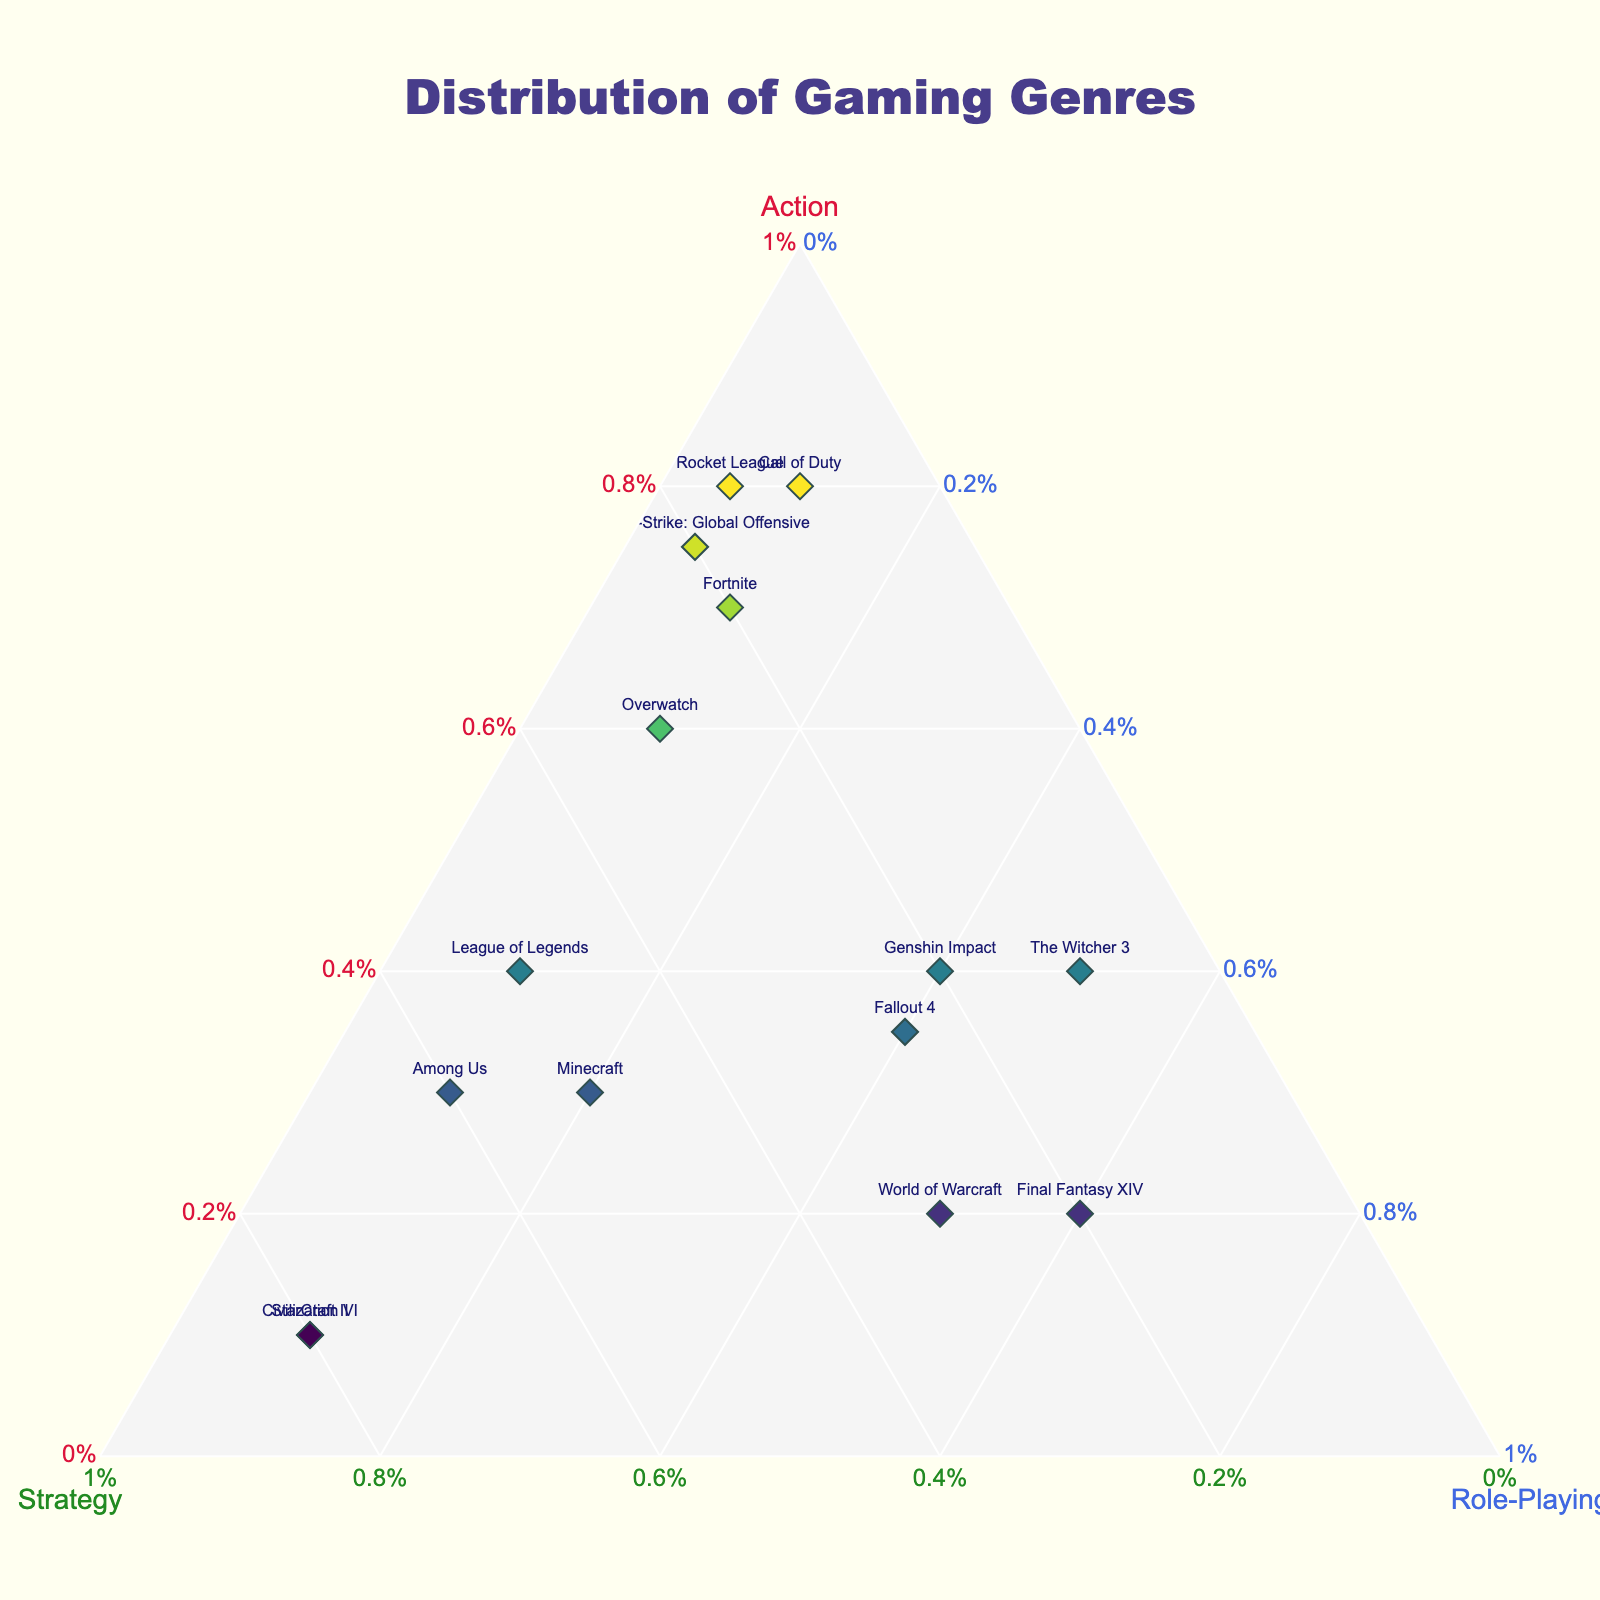What is the title of the plot? The title of the plot is usually located at the top center of the figure. It provides an overarching description of what the plot displays. Here, it's specified in the update layout function as "Distribution of Gaming Genres".
Answer: Distribution of Gaming Genres How many data points are there? To determine the number of data points, you can count the number of markers or text labels in the figure representing different games. Each game corresponds to one data point.
Answer: 15 Which game has the highest percentage of Action genre? To find this, look for the game located closest to the Action axis (usually labeled) with its highest value. From the data, "Call of Duty" has 80% in Action.
Answer: Call of Duty What is the average percentage of Strategy in the games? Summing up the Strategy percentages for all games (20+50+50+30+10+80+10+30+20+80+15+20+60+25+20) and then dividing by the number of games (15), the calculation is (570/15).
Answer: 38% Which games are equally divided between Action, Strategy, and Role-Playing? This involves identifying games where the percentages are close to being equal across the three genres. No game here fits perfectly, but Genshin Impact (40, 20, 40) and The Witcher 3 (40, 10, 50) are somewhat balanced.
Answer: None precisely, but Genshin Impact and The Witcher 3 are close Which game has the highest percentage of Role-Playing? Look for the game closest to the Role-Playing axis with its highest value in Role-Playing. From the data, "Final Fantasy XIV" has 60% in Role-Playing.
Answer: Final Fantasy XIV How do the Action percentages for 'League of Legends' and 'Rocket League' compare? League of Legends has 40% in Action and Rocket League has 80%. Comparing these values shows that Rocket League has double the Action percentage compared to League of Legends.
Answer: Rocket League has double the percentage of Action compared to League of Legends Which game is closest to the center of the ternary plot, indicating a balanced distribution among all three genres? The game closest to the center would have nearly equal values for Action, Strategy, and Role-Playing. Genshin Impact (40, 20, 40) and The Witcher 3 (40, 10, 50) are the most balanced as mentioned, but none are perfectly centered.
Answer: None perfectly, but Genshin Impact and The Witcher 3 are close Is there any game with exactly 80% in Strategy? By checking the Strategy values, you find that "Civilization VI" and "StarCraft II" both have 80% in Strategy.
Answer: Civilization VI and StarCraft II 